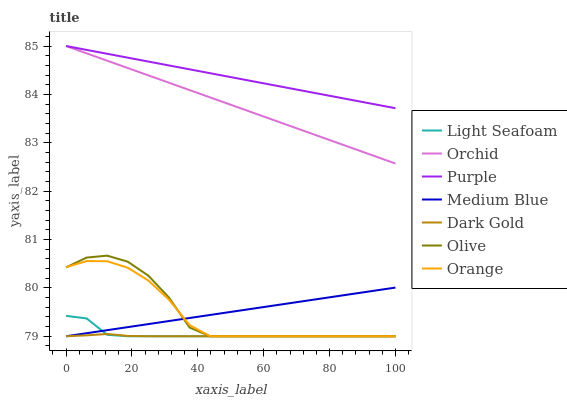Does Dark Gold have the minimum area under the curve?
Answer yes or no. Yes. Does Purple have the maximum area under the curve?
Answer yes or no. Yes. Does Medium Blue have the minimum area under the curve?
Answer yes or no. No. Does Medium Blue have the maximum area under the curve?
Answer yes or no. No. Is Purple the smoothest?
Answer yes or no. Yes. Is Olive the roughest?
Answer yes or no. Yes. Is Medium Blue the smoothest?
Answer yes or no. No. Is Medium Blue the roughest?
Answer yes or no. No. Does Dark Gold have the lowest value?
Answer yes or no. Yes. Does Purple have the lowest value?
Answer yes or no. No. Does Orchid have the highest value?
Answer yes or no. Yes. Does Medium Blue have the highest value?
Answer yes or no. No. Is Dark Gold less than Orchid?
Answer yes or no. Yes. Is Orchid greater than Light Seafoam?
Answer yes or no. Yes. Does Light Seafoam intersect Medium Blue?
Answer yes or no. Yes. Is Light Seafoam less than Medium Blue?
Answer yes or no. No. Is Light Seafoam greater than Medium Blue?
Answer yes or no. No. Does Dark Gold intersect Orchid?
Answer yes or no. No. 